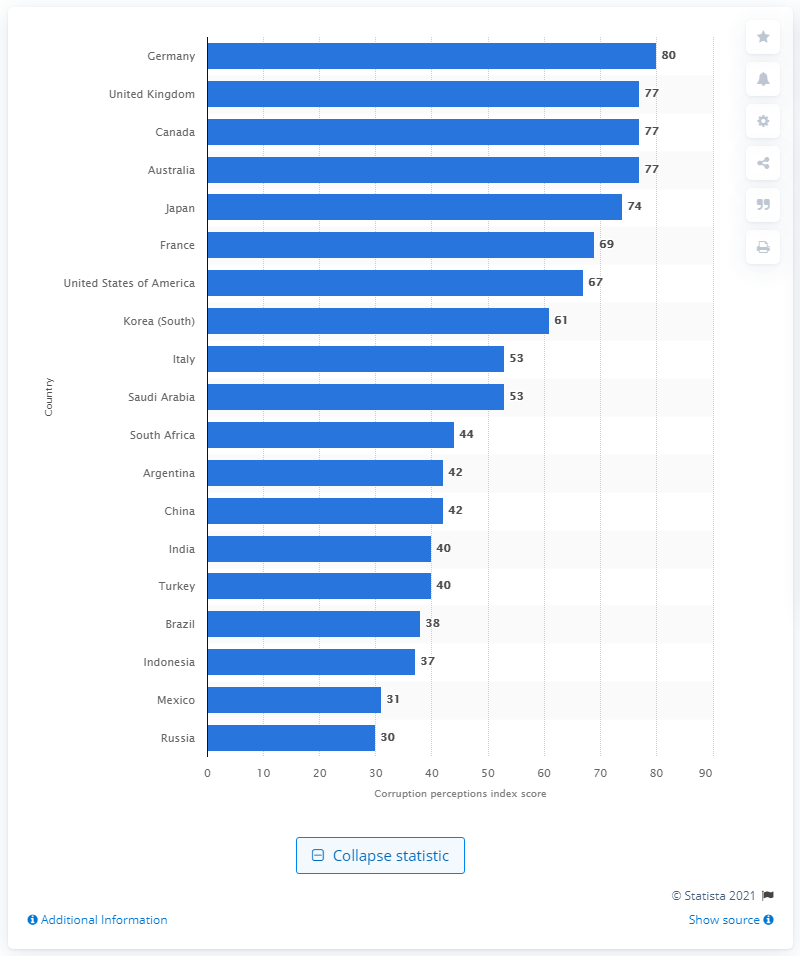Highlight a few significant elements in this photo. According to the Corruption Perceptions Index, Germany's score is 80. Russia was the most corrupt G20 country with a score of 30. Germany is the least corrupt country among the G20 nations. 